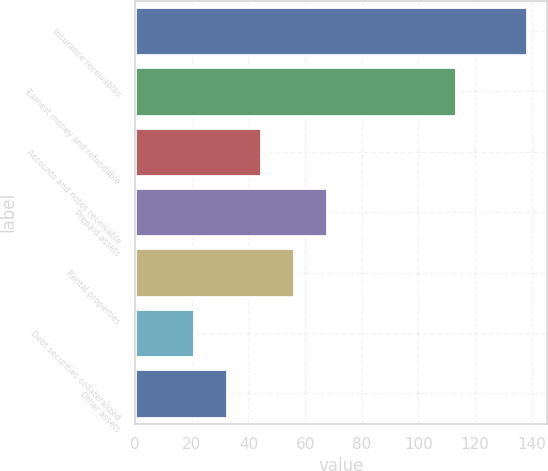<chart> <loc_0><loc_0><loc_500><loc_500><bar_chart><fcel>Insurance receivables<fcel>Earnest money and refundable<fcel>Accounts and notes receivable<fcel>Prepaid assets<fcel>Rental properties<fcel>Debt securities collateralized<fcel>Other assets<nl><fcel>138.4<fcel>113.3<fcel>44.32<fcel>67.84<fcel>56.08<fcel>20.8<fcel>32.56<nl></chart> 